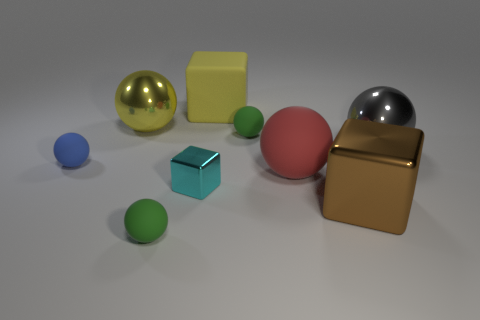What materials seem to be represented by the objects in the scene? The objects in the scene depict a variety of materials. The large cube appears matte and could represent a kind of plastic or painted surface. The two shiny spheres suggest metallic materials, and the smaller colored spheres could be either plastic or painted wood, given their smooth matte finish. 